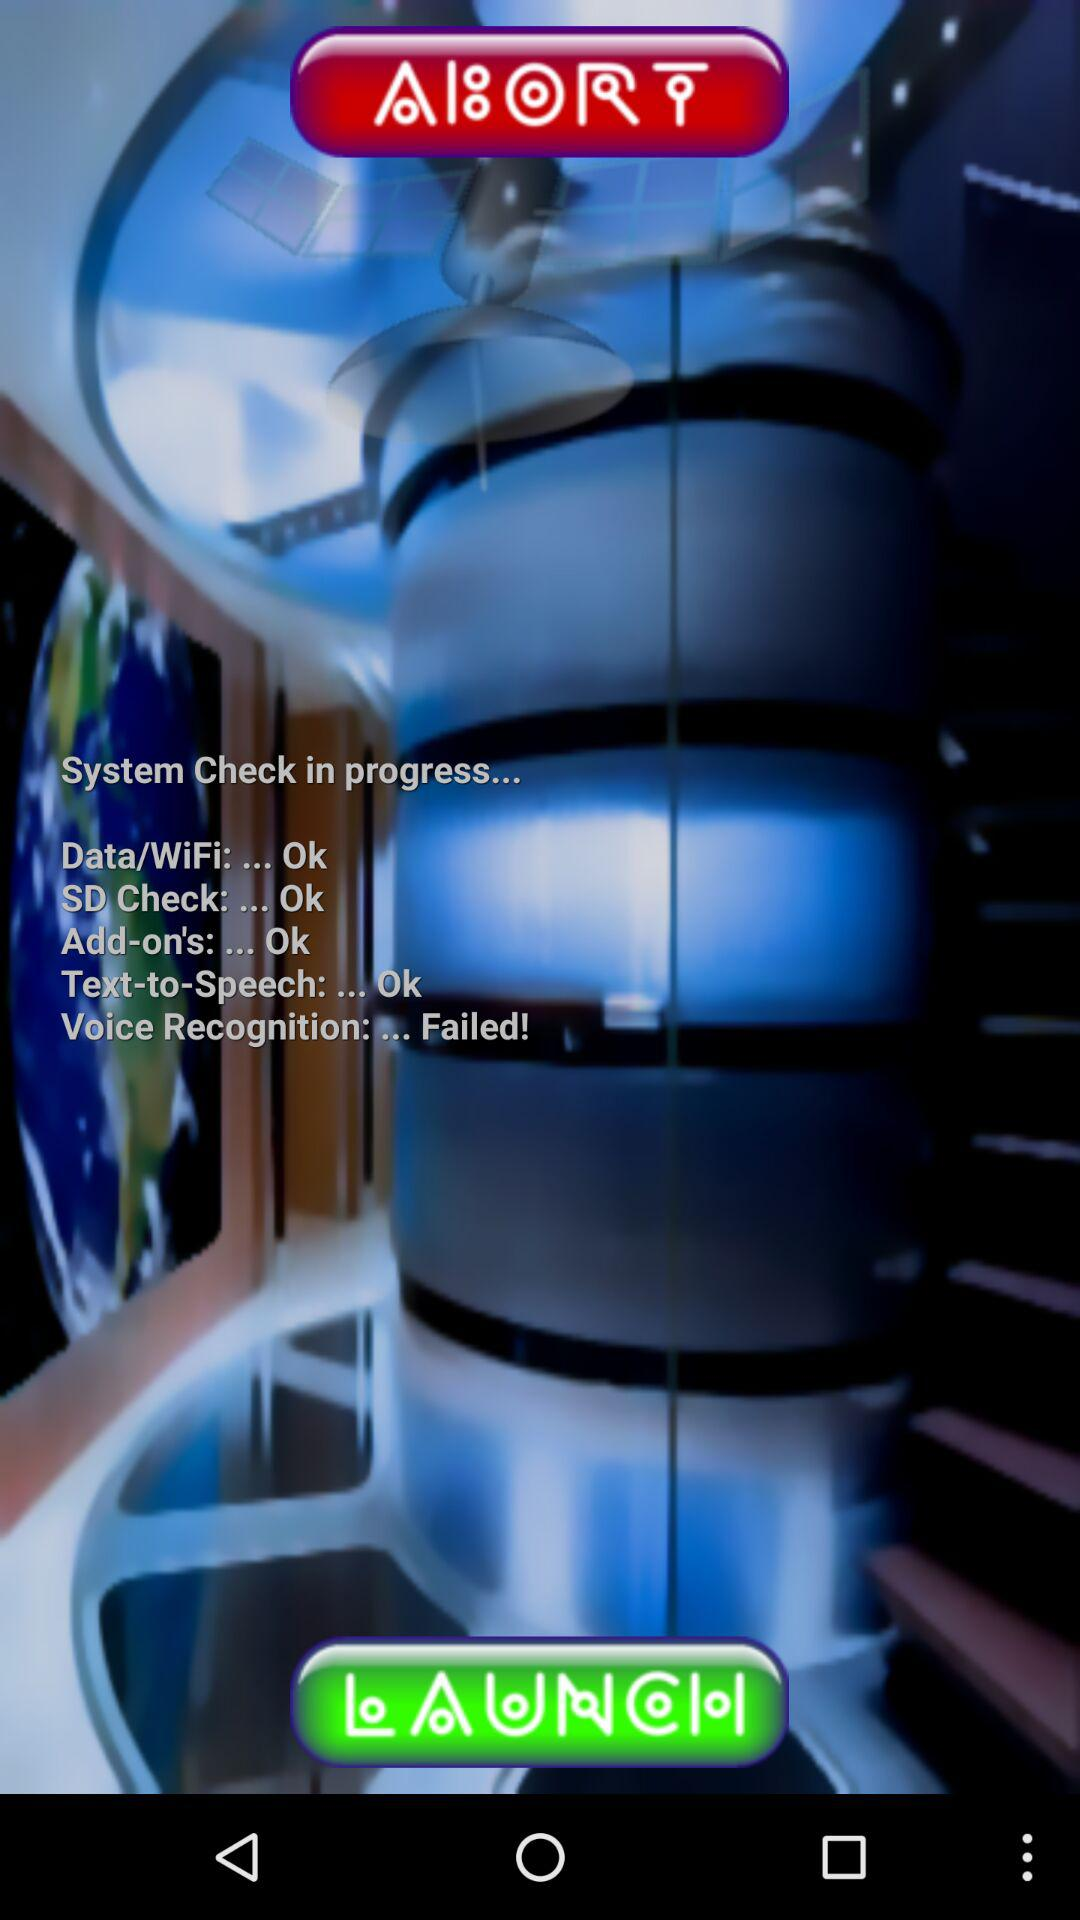How many tests failed?
Answer the question using a single word or phrase. 1 